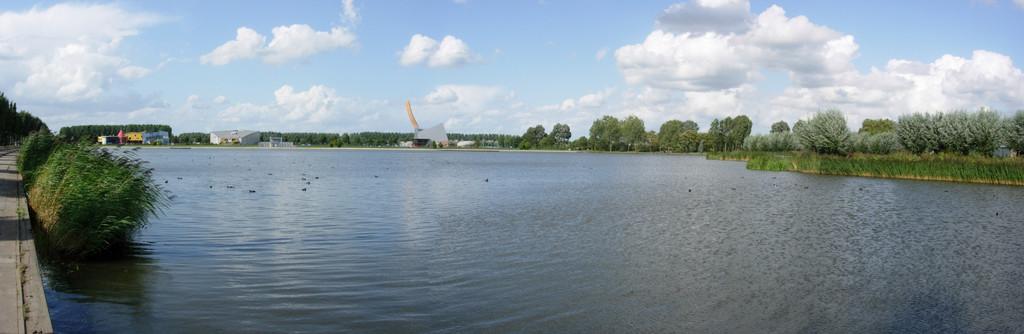In one or two sentences, can you explain what this image depicts? In this image I see the water and I see plants and the trees and I see few buildings and I see the path over here. In the background I see the sky. 